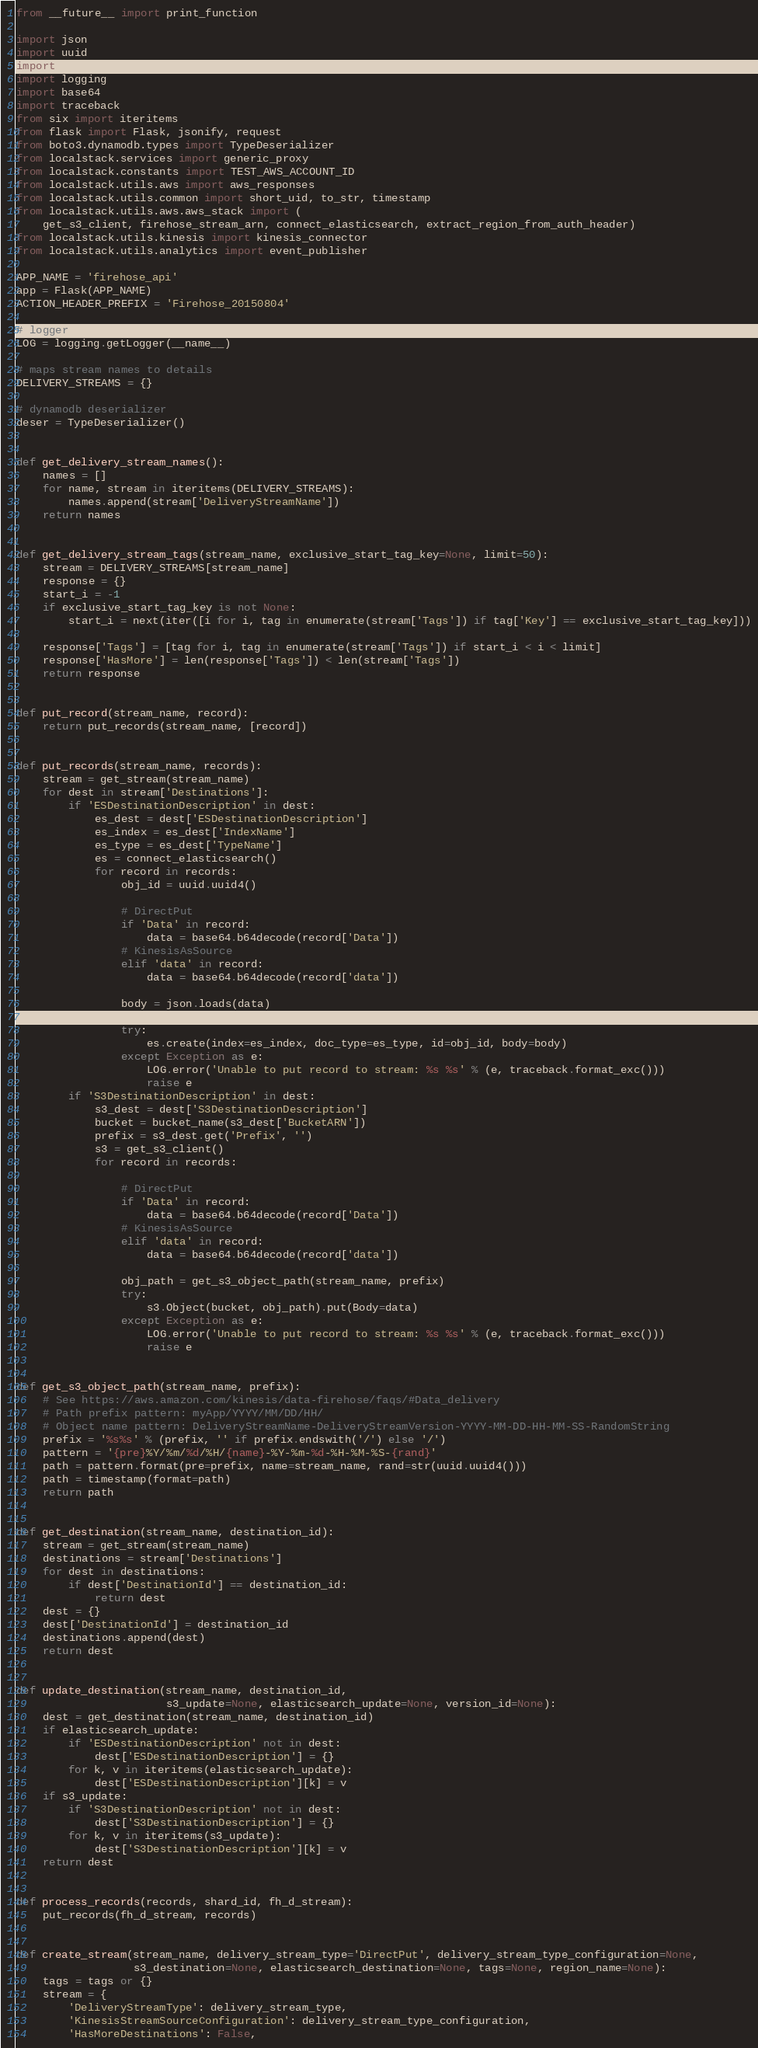<code> <loc_0><loc_0><loc_500><loc_500><_Python_>from __future__ import print_function

import json
import uuid
import time
import logging
import base64
import traceback
from six import iteritems
from flask import Flask, jsonify, request
from boto3.dynamodb.types import TypeDeserializer
from localstack.services import generic_proxy
from localstack.constants import TEST_AWS_ACCOUNT_ID
from localstack.utils.aws import aws_responses
from localstack.utils.common import short_uid, to_str, timestamp
from localstack.utils.aws.aws_stack import (
    get_s3_client, firehose_stream_arn, connect_elasticsearch, extract_region_from_auth_header)
from localstack.utils.kinesis import kinesis_connector
from localstack.utils.analytics import event_publisher

APP_NAME = 'firehose_api'
app = Flask(APP_NAME)
ACTION_HEADER_PREFIX = 'Firehose_20150804'

# logger
LOG = logging.getLogger(__name__)

# maps stream names to details
DELIVERY_STREAMS = {}

# dynamodb deserializer
deser = TypeDeserializer()


def get_delivery_stream_names():
    names = []
    for name, stream in iteritems(DELIVERY_STREAMS):
        names.append(stream['DeliveryStreamName'])
    return names


def get_delivery_stream_tags(stream_name, exclusive_start_tag_key=None, limit=50):
    stream = DELIVERY_STREAMS[stream_name]
    response = {}
    start_i = -1
    if exclusive_start_tag_key is not None:
        start_i = next(iter([i for i, tag in enumerate(stream['Tags']) if tag['Key'] == exclusive_start_tag_key]))

    response['Tags'] = [tag for i, tag in enumerate(stream['Tags']) if start_i < i < limit]
    response['HasMore'] = len(response['Tags']) < len(stream['Tags'])
    return response


def put_record(stream_name, record):
    return put_records(stream_name, [record])


def put_records(stream_name, records):
    stream = get_stream(stream_name)
    for dest in stream['Destinations']:
        if 'ESDestinationDescription' in dest:
            es_dest = dest['ESDestinationDescription']
            es_index = es_dest['IndexName']
            es_type = es_dest['TypeName']
            es = connect_elasticsearch()
            for record in records:
                obj_id = uuid.uuid4()

                # DirectPut
                if 'Data' in record:
                    data = base64.b64decode(record['Data'])
                # KinesisAsSource
                elif 'data' in record:
                    data = base64.b64decode(record['data'])

                body = json.loads(data)

                try:
                    es.create(index=es_index, doc_type=es_type, id=obj_id, body=body)
                except Exception as e:
                    LOG.error('Unable to put record to stream: %s %s' % (e, traceback.format_exc()))
                    raise e
        if 'S3DestinationDescription' in dest:
            s3_dest = dest['S3DestinationDescription']
            bucket = bucket_name(s3_dest['BucketARN'])
            prefix = s3_dest.get('Prefix', '')
            s3 = get_s3_client()
            for record in records:

                # DirectPut
                if 'Data' in record:
                    data = base64.b64decode(record['Data'])
                # KinesisAsSource
                elif 'data' in record:
                    data = base64.b64decode(record['data'])

                obj_path = get_s3_object_path(stream_name, prefix)
                try:
                    s3.Object(bucket, obj_path).put(Body=data)
                except Exception as e:
                    LOG.error('Unable to put record to stream: %s %s' % (e, traceback.format_exc()))
                    raise e


def get_s3_object_path(stream_name, prefix):
    # See https://aws.amazon.com/kinesis/data-firehose/faqs/#Data_delivery
    # Path prefix pattern: myApp/YYYY/MM/DD/HH/
    # Object name pattern: DeliveryStreamName-DeliveryStreamVersion-YYYY-MM-DD-HH-MM-SS-RandomString
    prefix = '%s%s' % (prefix, '' if prefix.endswith('/') else '/')
    pattern = '{pre}%Y/%m/%d/%H/{name}-%Y-%m-%d-%H-%M-%S-{rand}'
    path = pattern.format(pre=prefix, name=stream_name, rand=str(uuid.uuid4()))
    path = timestamp(format=path)
    return path


def get_destination(stream_name, destination_id):
    stream = get_stream(stream_name)
    destinations = stream['Destinations']
    for dest in destinations:
        if dest['DestinationId'] == destination_id:
            return dest
    dest = {}
    dest['DestinationId'] = destination_id
    destinations.append(dest)
    return dest


def update_destination(stream_name, destination_id,
                       s3_update=None, elasticsearch_update=None, version_id=None):
    dest = get_destination(stream_name, destination_id)
    if elasticsearch_update:
        if 'ESDestinationDescription' not in dest:
            dest['ESDestinationDescription'] = {}
        for k, v in iteritems(elasticsearch_update):
            dest['ESDestinationDescription'][k] = v
    if s3_update:
        if 'S3DestinationDescription' not in dest:
            dest['S3DestinationDescription'] = {}
        for k, v in iteritems(s3_update):
            dest['S3DestinationDescription'][k] = v
    return dest


def process_records(records, shard_id, fh_d_stream):
    put_records(fh_d_stream, records)


def create_stream(stream_name, delivery_stream_type='DirectPut', delivery_stream_type_configuration=None,
                  s3_destination=None, elasticsearch_destination=None, tags=None, region_name=None):
    tags = tags or {}
    stream = {
        'DeliveryStreamType': delivery_stream_type,
        'KinesisStreamSourceConfiguration': delivery_stream_type_configuration,
        'HasMoreDestinations': False,</code> 